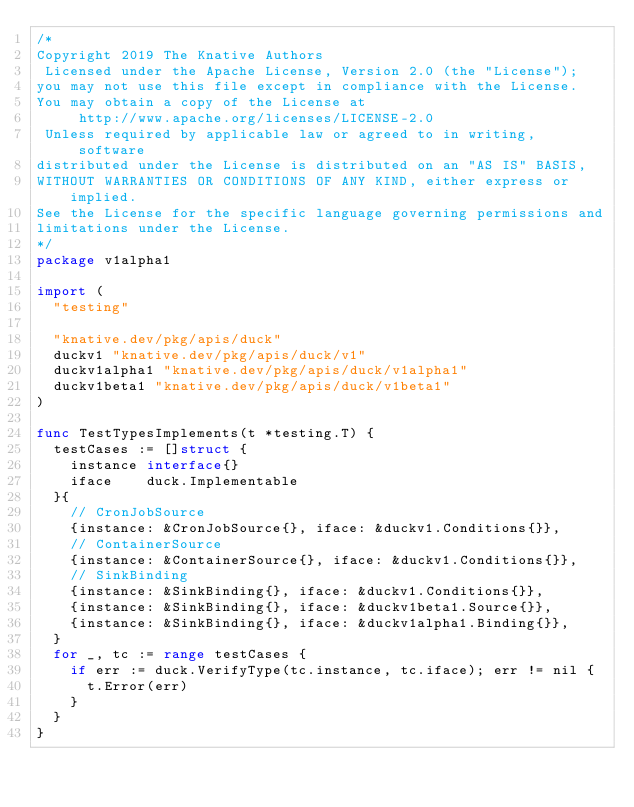<code> <loc_0><loc_0><loc_500><loc_500><_Go_>/*
Copyright 2019 The Knative Authors
 Licensed under the Apache License, Version 2.0 (the "License");
you may not use this file except in compliance with the License.
You may obtain a copy of the License at
     http://www.apache.org/licenses/LICENSE-2.0
 Unless required by applicable law or agreed to in writing, software
distributed under the License is distributed on an "AS IS" BASIS,
WITHOUT WARRANTIES OR CONDITIONS OF ANY KIND, either express or implied.
See the License for the specific language governing permissions and
limitations under the License.
*/
package v1alpha1

import (
	"testing"

	"knative.dev/pkg/apis/duck"
	duckv1 "knative.dev/pkg/apis/duck/v1"
	duckv1alpha1 "knative.dev/pkg/apis/duck/v1alpha1"
	duckv1beta1 "knative.dev/pkg/apis/duck/v1beta1"
)

func TestTypesImplements(t *testing.T) {
	testCases := []struct {
		instance interface{}
		iface    duck.Implementable
	}{
		// CronJobSource
		{instance: &CronJobSource{}, iface: &duckv1.Conditions{}},
		// ContainerSource
		{instance: &ContainerSource{}, iface: &duckv1.Conditions{}},
		// SinkBinding
		{instance: &SinkBinding{}, iface: &duckv1.Conditions{}},
		{instance: &SinkBinding{}, iface: &duckv1beta1.Source{}},
		{instance: &SinkBinding{}, iface: &duckv1alpha1.Binding{}},
	}
	for _, tc := range testCases {
		if err := duck.VerifyType(tc.instance, tc.iface); err != nil {
			t.Error(err)
		}
	}
}
</code> 